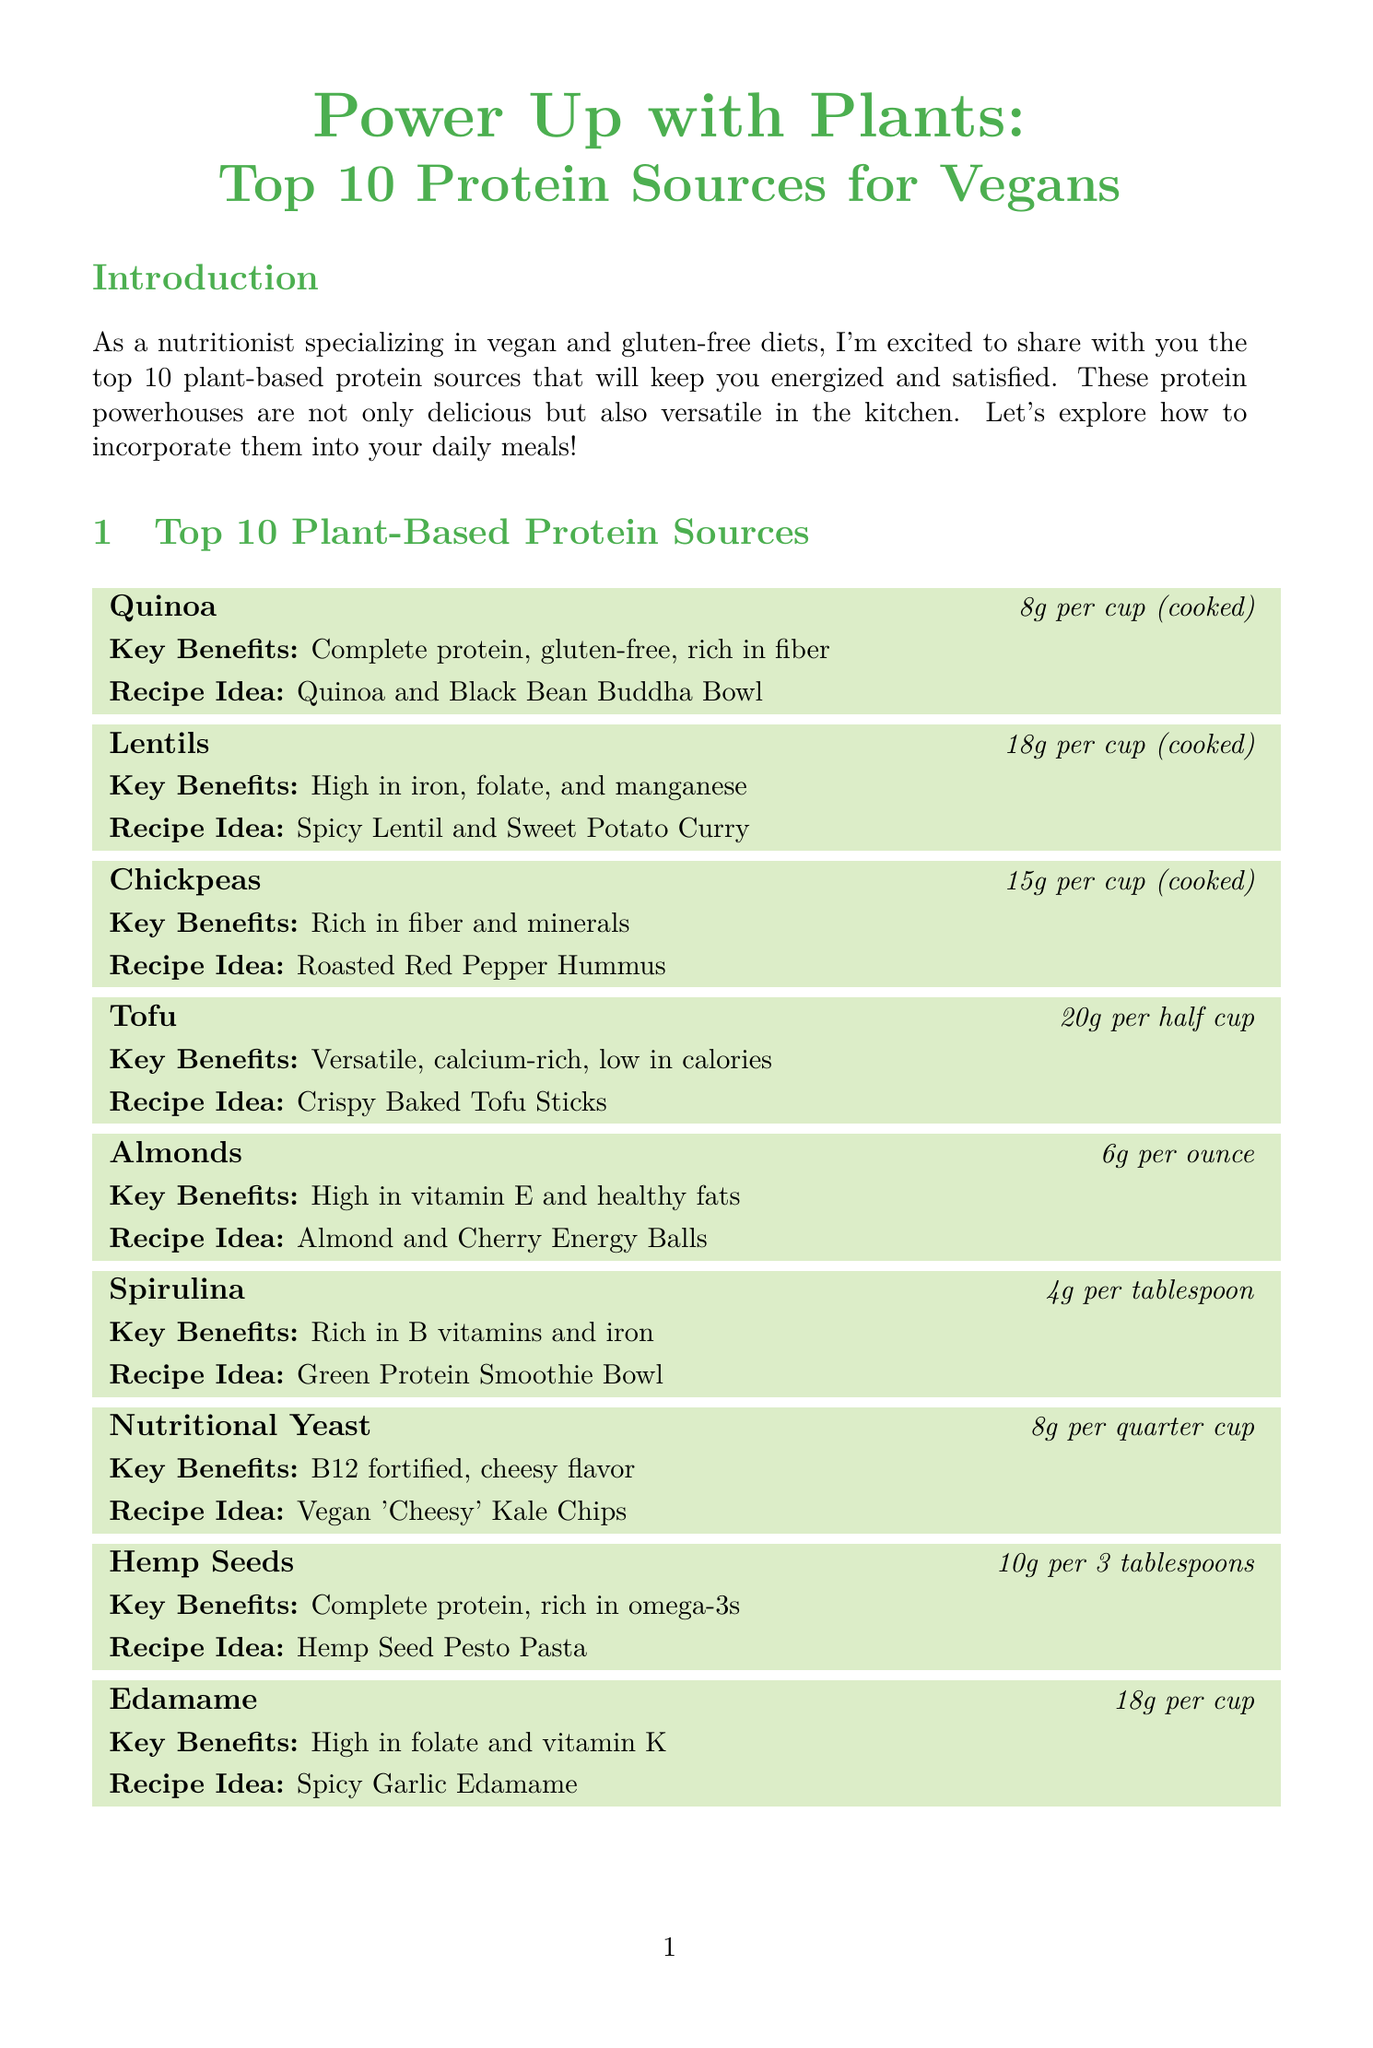What is the title of the newsletter? The title can be found at the beginning of the document, stating the main theme of the content.
Answer: Power Up with Plants: Top 10 Protein Sources for Vegans How much protein is in a cup of lentils? The protein content for lentils is specified within the section for lentils.
Answer: 18g per cup (cooked) What recipe idea is suggested for chickpeas? The recipe idea for chickpeas can be found in the specific section detailing chickpeas as a protein source.
Answer: Roasted Red Pepper Hummus Which protein source has the highest protein content? The highest protein content is mentioned next to the corresponding protein source in the list.
Answer: Tempeh What is a key benefit of quinoa? The document lists key benefits for each protein source, including quinoa.
Answer: Complete protein, gluten-free, rich in fiber What is the gluten-free note? The gluten-free note summarizes information about the protein sources' suitability for specific dietary needs.
Answer: All featured protein sources are naturally gluten-free How many grams of protein are in hemp seeds? The protein content for hemp seeds is provided in the section detailing hemp seeds.
Answer: 10g per 3 tablespoons What is a substitution tip related to baking? The substitution tips provide alternative ingredient options for baking in a gluten-free context.
Answer: Use chickpea flour as a gluten-free alternative to wheat flour in baking Which protein source is rich in vitamin E? The essential nutrients and benefits for each protein source include vitamins and their presence.
Answer: Almonds 